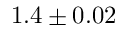<formula> <loc_0><loc_0><loc_500><loc_500>1 . 4 \pm 0 . 0 2</formula> 